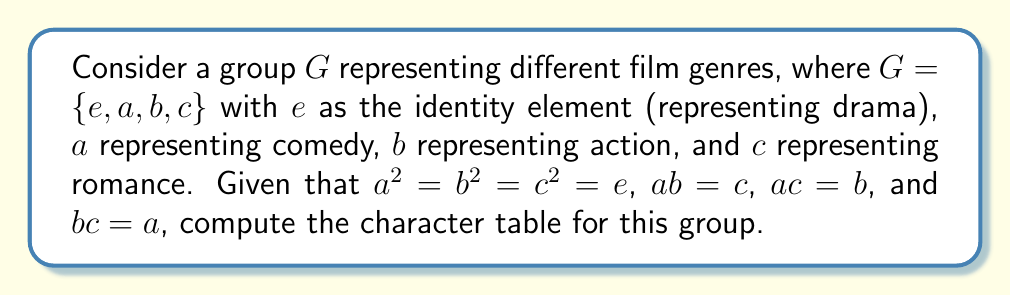Could you help me with this problem? To compute the character table for this group, we'll follow these steps:

1) First, identify the conjugacy classes:
   - $\{e\}$ (identity)
   - $\{a\}$ (comedy)
   - $\{b\}$ (action)
   - $\{c\}$ (romance)
   Each element forms its own conjugacy class as the group is abelian.

2) The number of irreducible representations equals the number of conjugacy classes, so we have 4 irreducible representations.

3) For an abelian group, all irreducible representations are 1-dimensional.

4) The first row of the character table always corresponds to the trivial representation, where all elements map to 1.

5) For the remaining representations, we need to ensure orthogonality. Let's call our representations $\chi_1, \chi_2, \chi_3, \chi_4$.

6) Given the relations $a^2 = b^2 = c^2 = e$, we know that $\chi_i(a), \chi_i(b), \chi_i(c)$ must be either 1 or -1 for all $i$.

7) To ensure orthogonality and considering the group structure, we can deduce:
   $\chi_2(a) = -1, \chi_2(b) = -1, \chi_2(c) = 1$
   $\chi_3(a) = -1, \chi_3(b) = 1, \chi_3(c) = -1$
   $\chi_4(a) = 1, \chi_4(b) = -1, \chi_4(c) = -1$

8) The resulting character table is:

   $$
   \begin{array}{c|cccc}
    G & e & a & b & c \\
    \hline
    \chi_1 & 1 & 1 & 1 & 1 \\
    \chi_2 & 1 & -1 & -1 & 1 \\
    \chi_3 & 1 & -1 & 1 & -1 \\
    \chi_4 & 1 & 1 & -1 & -1
   \end{array}
   $$

This character table reflects how each irreducible representation acts on the different "genre" elements of the group.
Answer: $$
\begin{array}{c|cccc}
G & e & a & b & c \\
\hline
\chi_1 & 1 & 1 & 1 & 1 \\
\chi_2 & 1 & -1 & -1 & 1 \\
\chi_3 & 1 & -1 & 1 & -1 \\
\chi_4 & 1 & 1 & -1 & -1
\end{array}
$$ 